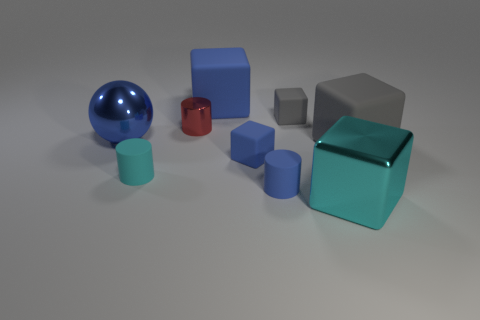Can you tell me what the largest object in the image is? The largest object in the image is the big metallic cube positioned roughly in the center. It has a highly reflective surface and seems to be the most dominant object in the scene. 